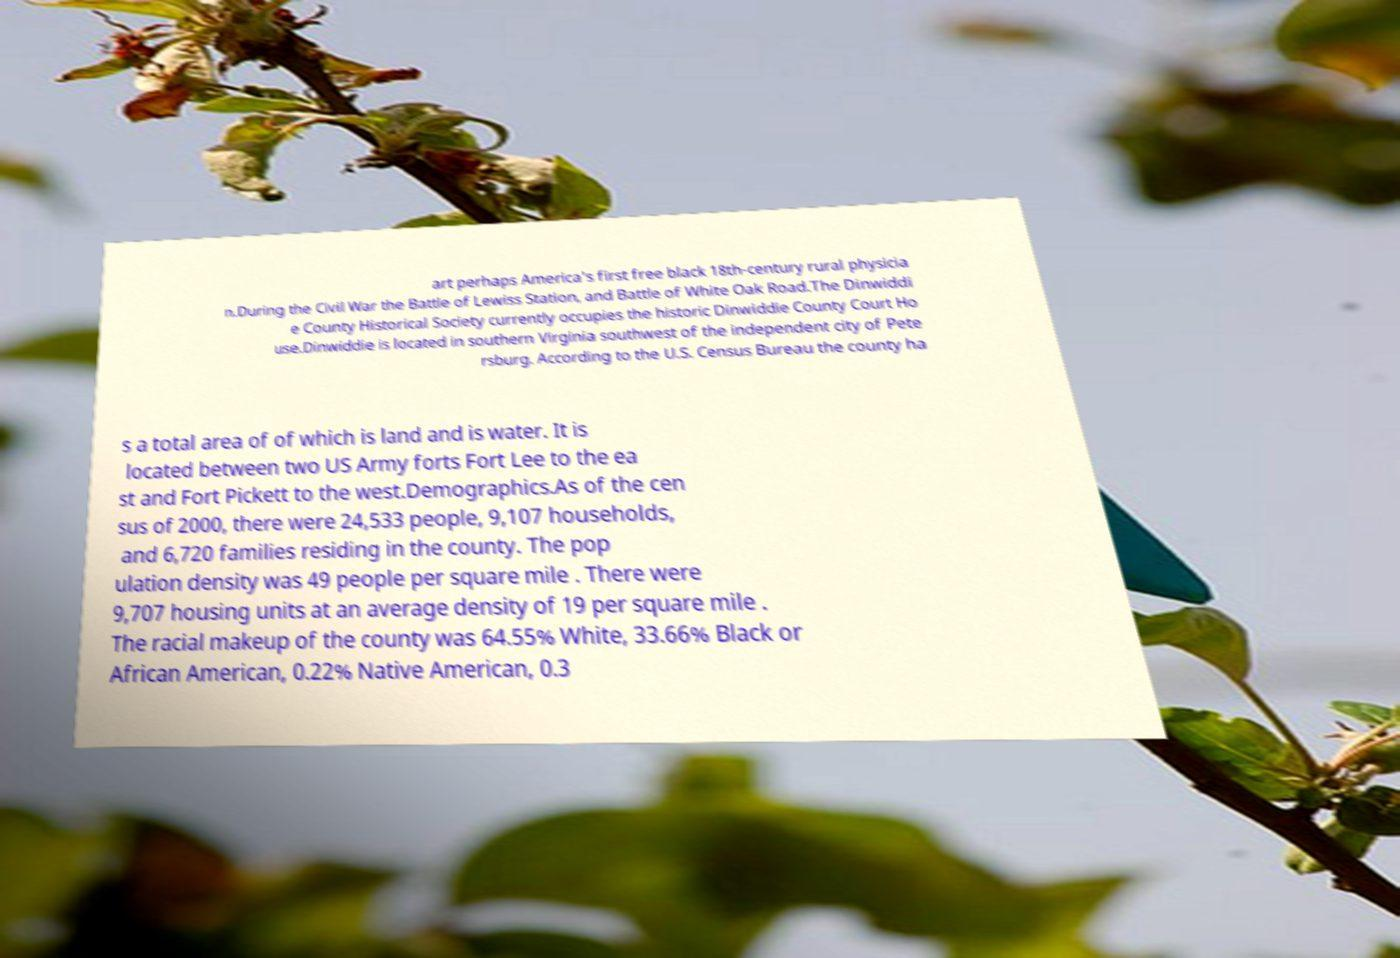There's text embedded in this image that I need extracted. Can you transcribe it verbatim? art perhaps America's first free black 18th-century rural physicia n.During the Civil War the Battle of Lewiss Station, and Battle of White Oak Road.The Dinwiddi e County Historical Society currently occupies the historic Dinwiddie County Court Ho use.Dinwiddie is located in southern Virginia southwest of the independent city of Pete rsburg. According to the U.S. Census Bureau the county ha s a total area of of which is land and is water. It is located between two US Army forts Fort Lee to the ea st and Fort Pickett to the west.Demographics.As of the cen sus of 2000, there were 24,533 people, 9,107 households, and 6,720 families residing in the county. The pop ulation density was 49 people per square mile . There were 9,707 housing units at an average density of 19 per square mile . The racial makeup of the county was 64.55% White, 33.66% Black or African American, 0.22% Native American, 0.3 